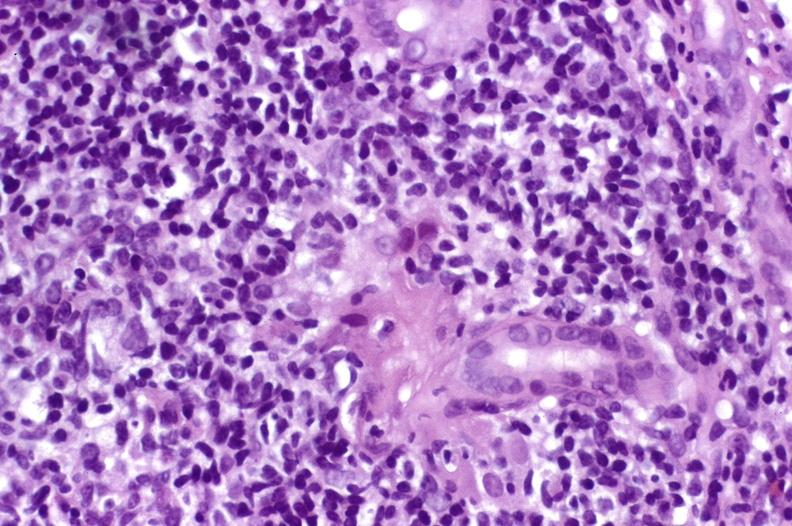s liver present?
Answer the question using a single word or phrase. Yes 